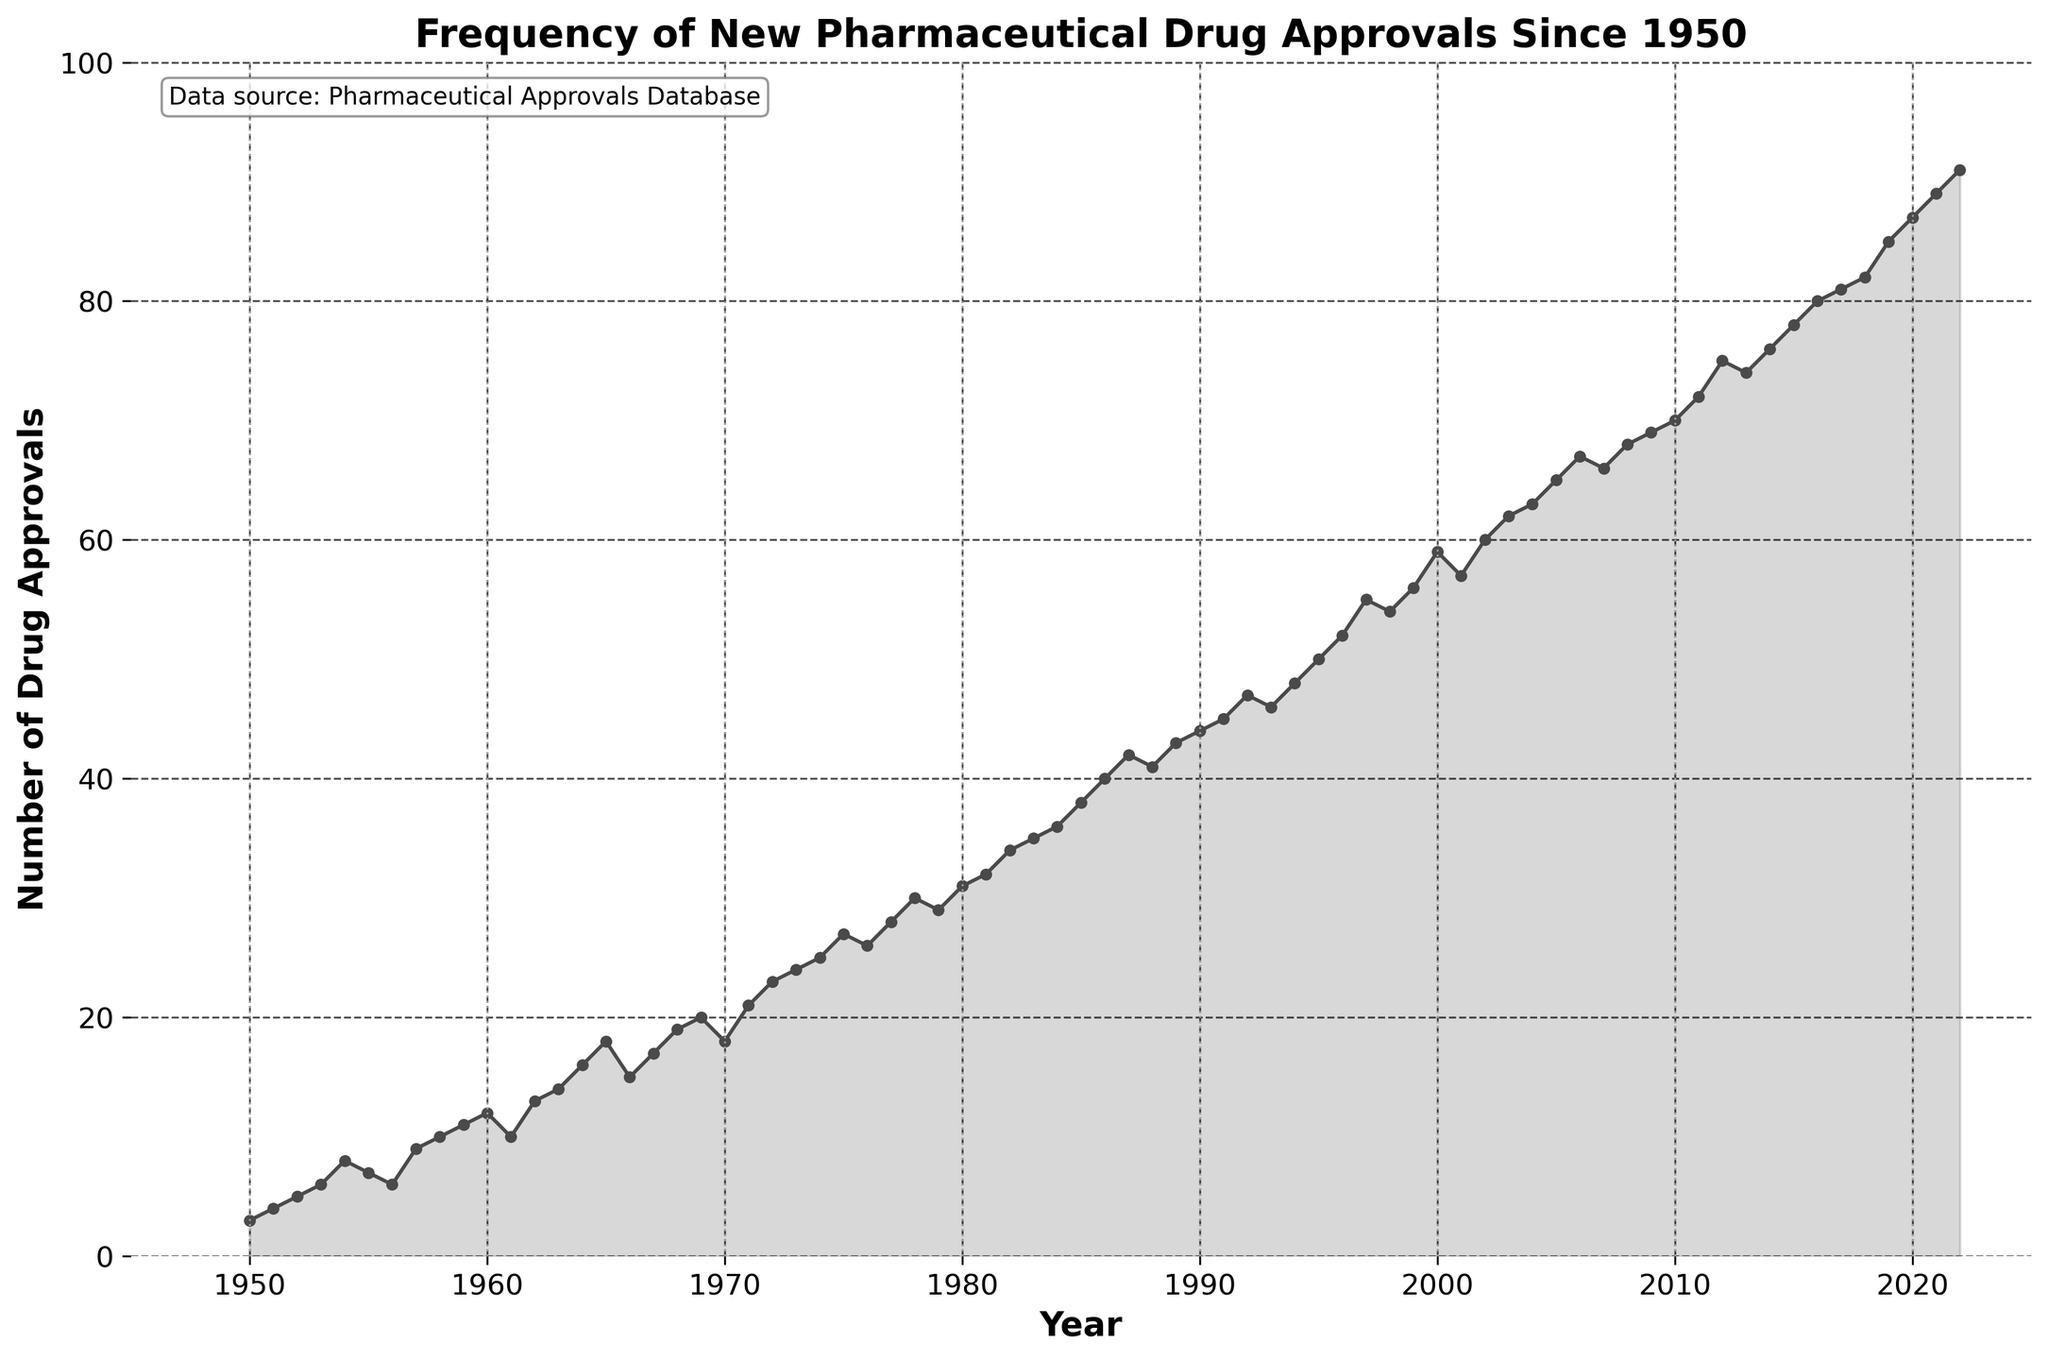What is the title of the plot? The title is located at the top of the plot and summarizes the content of the figure. By reading it, you can determine that the plot is about the "Frequency of New Pharmaceutical Drug Approvals Since 1950".
Answer: Frequency of New Pharmaceutical Drug Approvals Since 1950 What are the labels of the X and Y axes? The axis labels are typically found on the horizontal and vertical lines of the plot. In this case, the X-axis is labeled "Year" and the Y-axis is labeled "Number of Drug Approvals".
Answer: Year, Number of Drug Approvals What is the trend in the number of drug approvals over the years depicted in the plot? By observing the plot, you can see that the number of drug approvals has generally increased from 1950 to 2022. This can be deduced from the overall upward trajectory of the line.
Answer: An overall increase Which year had the highest number of drug approvals? The highest point on the Y-axis line represents the year with the most approvals. According to the plot, the year 2022 had the highest number, reaching 91.
Answer: 2022 How many drug approvals were there in the year 2000? Locate the year 2000 on the X-axis and find where it intersects the plotted line. The corresponding Y-axis value for 2000 is 59.
Answer: 59 Between which consecutive years was the greatest increase in drug approvals observed? To find the greatest increase, look at the differences between consecutive points on the Y-axis. The largest jump is from 1999 (56) to 2000 (59), with an increase of 3.
Answer: 1999 to 2000 How many ten-year intervals are marked with vertical dashed lines? Counting the vertical dashed lines at regular intervals of 10 years apart, starting from 1950, there are 8 lines (1960, 1970, 1980, 1990, 2000, 2010, and 2020).
Answer: 8 What was the number of drug approvals in 1985, and how does it compare to the number in 1995? Locate 1985 and 1995 on the X-axis and read the corresponding Y-axis values. There were 38 approvals in 1985 and 50 in 1995, so the number increased by 12 over this period.
Answer: 38 in 1985, 50 in 1995; an increase of 12 Did the number of drug approvals ever decrease in two consecutive years? If so, when? To identify decreases, look for points where the line drops between two consecutive years. One instance is from 1998 (54) to 1999 (56), and from 2007 (66) to 2008 (68).
Answer: Yes, from 1998 to 1999, and from 2007 to 2008 What range of years does the X-axis cover, and what are the minimum and maximum Y-axis values? The X-axis spans from just before 1950 to just after 2022. The Y-axis ranges from 0 to slightly above 91, which is 1.1 times the highest data point.
Answer: X-axis: 1945 to 2025, Y-axis: 0 to 100 